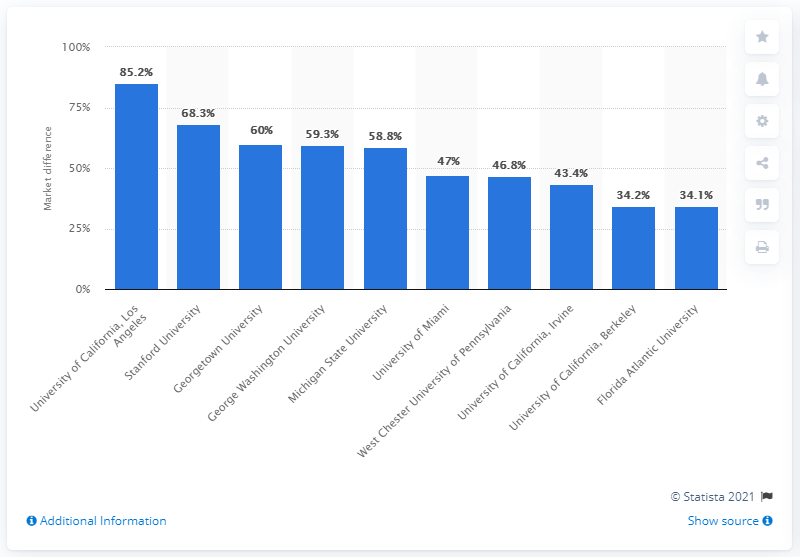List a handful of essential elements in this visual. In 2017, the average off-campus rent near Stanford University was 68.3.. In 2017, Stanford University was the second most expensive college town for off-campus rents, with off-campus rents exceeding the national average by a significant margin. 